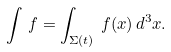Convert formula to latex. <formula><loc_0><loc_0><loc_500><loc_500>\int \, f = \int _ { \Sigma ( t ) } \, f ( x ) \, d ^ { 3 } x .</formula> 